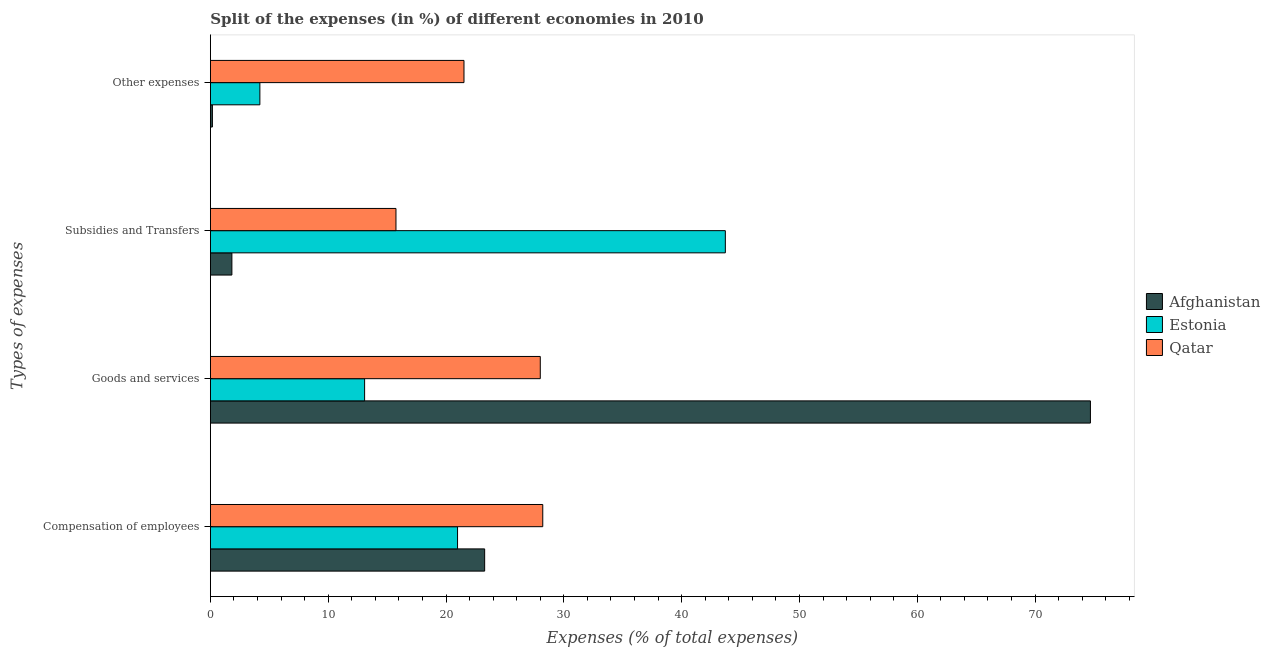How many different coloured bars are there?
Provide a succinct answer. 3. Are the number of bars on each tick of the Y-axis equal?
Your answer should be very brief. Yes. How many bars are there on the 1st tick from the top?
Provide a succinct answer. 3. How many bars are there on the 4th tick from the bottom?
Make the answer very short. 3. What is the label of the 3rd group of bars from the top?
Give a very brief answer. Goods and services. What is the percentage of amount spent on other expenses in Afghanistan?
Provide a succinct answer. 0.17. Across all countries, what is the maximum percentage of amount spent on goods and services?
Provide a short and direct response. 74.7. Across all countries, what is the minimum percentage of amount spent on subsidies?
Offer a very short reply. 1.82. In which country was the percentage of amount spent on compensation of employees maximum?
Offer a very short reply. Qatar. In which country was the percentage of amount spent on other expenses minimum?
Make the answer very short. Afghanistan. What is the total percentage of amount spent on goods and services in the graph?
Keep it short and to the point. 115.79. What is the difference between the percentage of amount spent on subsidies in Qatar and that in Afghanistan?
Ensure brevity in your answer.  13.93. What is the difference between the percentage of amount spent on compensation of employees in Estonia and the percentage of amount spent on subsidies in Qatar?
Ensure brevity in your answer.  5.23. What is the average percentage of amount spent on goods and services per country?
Keep it short and to the point. 38.6. What is the difference between the percentage of amount spent on goods and services and percentage of amount spent on compensation of employees in Estonia?
Offer a terse response. -7.89. What is the ratio of the percentage of amount spent on goods and services in Estonia to that in Afghanistan?
Your response must be concise. 0.18. Is the percentage of amount spent on goods and services in Estonia less than that in Afghanistan?
Offer a very short reply. Yes. What is the difference between the highest and the second highest percentage of amount spent on compensation of employees?
Your answer should be very brief. 4.93. What is the difference between the highest and the lowest percentage of amount spent on compensation of employees?
Give a very brief answer. 7.23. Is the sum of the percentage of amount spent on other expenses in Qatar and Estonia greater than the maximum percentage of amount spent on compensation of employees across all countries?
Ensure brevity in your answer.  No. What does the 3rd bar from the top in Compensation of employees represents?
Provide a succinct answer. Afghanistan. What does the 2nd bar from the bottom in Compensation of employees represents?
Give a very brief answer. Estonia. Is it the case that in every country, the sum of the percentage of amount spent on compensation of employees and percentage of amount spent on goods and services is greater than the percentage of amount spent on subsidies?
Your answer should be compact. No. How many bars are there?
Keep it short and to the point. 12. Are all the bars in the graph horizontal?
Offer a terse response. Yes. How many countries are there in the graph?
Make the answer very short. 3. What is the difference between two consecutive major ticks on the X-axis?
Offer a very short reply. 10. Are the values on the major ticks of X-axis written in scientific E-notation?
Give a very brief answer. No. Does the graph contain any zero values?
Your answer should be very brief. No. How are the legend labels stacked?
Your answer should be very brief. Vertical. What is the title of the graph?
Offer a terse response. Split of the expenses (in %) of different economies in 2010. What is the label or title of the X-axis?
Your answer should be very brief. Expenses (% of total expenses). What is the label or title of the Y-axis?
Provide a succinct answer. Types of expenses. What is the Expenses (% of total expenses) in Afghanistan in Compensation of employees?
Offer a very short reply. 23.28. What is the Expenses (% of total expenses) of Estonia in Compensation of employees?
Ensure brevity in your answer.  20.98. What is the Expenses (% of total expenses) in Qatar in Compensation of employees?
Your answer should be compact. 28.21. What is the Expenses (% of total expenses) in Afghanistan in Goods and services?
Provide a succinct answer. 74.7. What is the Expenses (% of total expenses) in Estonia in Goods and services?
Provide a succinct answer. 13.09. What is the Expenses (% of total expenses) in Qatar in Goods and services?
Ensure brevity in your answer.  28. What is the Expenses (% of total expenses) of Afghanistan in Subsidies and Transfers?
Make the answer very short. 1.82. What is the Expenses (% of total expenses) in Estonia in Subsidies and Transfers?
Offer a terse response. 43.71. What is the Expenses (% of total expenses) of Qatar in Subsidies and Transfers?
Provide a succinct answer. 15.75. What is the Expenses (% of total expenses) in Afghanistan in Other expenses?
Ensure brevity in your answer.  0.17. What is the Expenses (% of total expenses) of Estonia in Other expenses?
Offer a very short reply. 4.2. What is the Expenses (% of total expenses) of Qatar in Other expenses?
Provide a succinct answer. 21.53. Across all Types of expenses, what is the maximum Expenses (% of total expenses) of Afghanistan?
Give a very brief answer. 74.7. Across all Types of expenses, what is the maximum Expenses (% of total expenses) of Estonia?
Provide a succinct answer. 43.71. Across all Types of expenses, what is the maximum Expenses (% of total expenses) of Qatar?
Make the answer very short. 28.21. Across all Types of expenses, what is the minimum Expenses (% of total expenses) of Afghanistan?
Ensure brevity in your answer.  0.17. Across all Types of expenses, what is the minimum Expenses (% of total expenses) in Estonia?
Keep it short and to the point. 4.2. Across all Types of expenses, what is the minimum Expenses (% of total expenses) of Qatar?
Your answer should be very brief. 15.75. What is the total Expenses (% of total expenses) of Afghanistan in the graph?
Your answer should be very brief. 99.98. What is the total Expenses (% of total expenses) of Estonia in the graph?
Give a very brief answer. 81.98. What is the total Expenses (% of total expenses) in Qatar in the graph?
Make the answer very short. 93.49. What is the difference between the Expenses (% of total expenses) in Afghanistan in Compensation of employees and that in Goods and services?
Ensure brevity in your answer.  -51.42. What is the difference between the Expenses (% of total expenses) in Estonia in Compensation of employees and that in Goods and services?
Offer a terse response. 7.89. What is the difference between the Expenses (% of total expenses) in Qatar in Compensation of employees and that in Goods and services?
Provide a short and direct response. 0.21. What is the difference between the Expenses (% of total expenses) in Afghanistan in Compensation of employees and that in Subsidies and Transfers?
Provide a succinct answer. 21.46. What is the difference between the Expenses (% of total expenses) in Estonia in Compensation of employees and that in Subsidies and Transfers?
Your response must be concise. -22.73. What is the difference between the Expenses (% of total expenses) of Qatar in Compensation of employees and that in Subsidies and Transfers?
Make the answer very short. 12.46. What is the difference between the Expenses (% of total expenses) in Afghanistan in Compensation of employees and that in Other expenses?
Your answer should be compact. 23.11. What is the difference between the Expenses (% of total expenses) of Estonia in Compensation of employees and that in Other expenses?
Keep it short and to the point. 16.78. What is the difference between the Expenses (% of total expenses) of Qatar in Compensation of employees and that in Other expenses?
Ensure brevity in your answer.  6.69. What is the difference between the Expenses (% of total expenses) of Afghanistan in Goods and services and that in Subsidies and Transfers?
Offer a very short reply. 72.88. What is the difference between the Expenses (% of total expenses) of Estonia in Goods and services and that in Subsidies and Transfers?
Give a very brief answer. -30.62. What is the difference between the Expenses (% of total expenses) of Qatar in Goods and services and that in Subsidies and Transfers?
Provide a short and direct response. 12.25. What is the difference between the Expenses (% of total expenses) in Afghanistan in Goods and services and that in Other expenses?
Your response must be concise. 74.53. What is the difference between the Expenses (% of total expenses) of Estonia in Goods and services and that in Other expenses?
Provide a short and direct response. 8.89. What is the difference between the Expenses (% of total expenses) of Qatar in Goods and services and that in Other expenses?
Ensure brevity in your answer.  6.48. What is the difference between the Expenses (% of total expenses) in Afghanistan in Subsidies and Transfers and that in Other expenses?
Your answer should be very brief. 1.65. What is the difference between the Expenses (% of total expenses) of Estonia in Subsidies and Transfers and that in Other expenses?
Provide a succinct answer. 39.51. What is the difference between the Expenses (% of total expenses) in Qatar in Subsidies and Transfers and that in Other expenses?
Offer a very short reply. -5.77. What is the difference between the Expenses (% of total expenses) of Afghanistan in Compensation of employees and the Expenses (% of total expenses) of Estonia in Goods and services?
Your answer should be very brief. 10.19. What is the difference between the Expenses (% of total expenses) of Afghanistan in Compensation of employees and the Expenses (% of total expenses) of Qatar in Goods and services?
Ensure brevity in your answer.  -4.72. What is the difference between the Expenses (% of total expenses) of Estonia in Compensation of employees and the Expenses (% of total expenses) of Qatar in Goods and services?
Provide a short and direct response. -7.02. What is the difference between the Expenses (% of total expenses) in Afghanistan in Compensation of employees and the Expenses (% of total expenses) in Estonia in Subsidies and Transfers?
Your answer should be very brief. -20.43. What is the difference between the Expenses (% of total expenses) of Afghanistan in Compensation of employees and the Expenses (% of total expenses) of Qatar in Subsidies and Transfers?
Offer a terse response. 7.53. What is the difference between the Expenses (% of total expenses) of Estonia in Compensation of employees and the Expenses (% of total expenses) of Qatar in Subsidies and Transfers?
Make the answer very short. 5.23. What is the difference between the Expenses (% of total expenses) in Afghanistan in Compensation of employees and the Expenses (% of total expenses) in Estonia in Other expenses?
Offer a terse response. 19.08. What is the difference between the Expenses (% of total expenses) in Afghanistan in Compensation of employees and the Expenses (% of total expenses) in Qatar in Other expenses?
Keep it short and to the point. 1.75. What is the difference between the Expenses (% of total expenses) in Estonia in Compensation of employees and the Expenses (% of total expenses) in Qatar in Other expenses?
Provide a short and direct response. -0.55. What is the difference between the Expenses (% of total expenses) of Afghanistan in Goods and services and the Expenses (% of total expenses) of Estonia in Subsidies and Transfers?
Your answer should be very brief. 30.99. What is the difference between the Expenses (% of total expenses) in Afghanistan in Goods and services and the Expenses (% of total expenses) in Qatar in Subsidies and Transfers?
Provide a succinct answer. 58.95. What is the difference between the Expenses (% of total expenses) in Estonia in Goods and services and the Expenses (% of total expenses) in Qatar in Subsidies and Transfers?
Your answer should be very brief. -2.66. What is the difference between the Expenses (% of total expenses) of Afghanistan in Goods and services and the Expenses (% of total expenses) of Estonia in Other expenses?
Offer a very short reply. 70.5. What is the difference between the Expenses (% of total expenses) of Afghanistan in Goods and services and the Expenses (% of total expenses) of Qatar in Other expenses?
Your response must be concise. 53.17. What is the difference between the Expenses (% of total expenses) of Estonia in Goods and services and the Expenses (% of total expenses) of Qatar in Other expenses?
Offer a terse response. -8.44. What is the difference between the Expenses (% of total expenses) in Afghanistan in Subsidies and Transfers and the Expenses (% of total expenses) in Estonia in Other expenses?
Provide a succinct answer. -2.38. What is the difference between the Expenses (% of total expenses) of Afghanistan in Subsidies and Transfers and the Expenses (% of total expenses) of Qatar in Other expenses?
Offer a terse response. -19.7. What is the difference between the Expenses (% of total expenses) in Estonia in Subsidies and Transfers and the Expenses (% of total expenses) in Qatar in Other expenses?
Make the answer very short. 22.18. What is the average Expenses (% of total expenses) in Afghanistan per Types of expenses?
Make the answer very short. 24.99. What is the average Expenses (% of total expenses) in Estonia per Types of expenses?
Offer a terse response. 20.5. What is the average Expenses (% of total expenses) of Qatar per Types of expenses?
Provide a succinct answer. 23.37. What is the difference between the Expenses (% of total expenses) in Afghanistan and Expenses (% of total expenses) in Estonia in Compensation of employees?
Provide a succinct answer. 2.3. What is the difference between the Expenses (% of total expenses) of Afghanistan and Expenses (% of total expenses) of Qatar in Compensation of employees?
Your answer should be compact. -4.93. What is the difference between the Expenses (% of total expenses) in Estonia and Expenses (% of total expenses) in Qatar in Compensation of employees?
Offer a very short reply. -7.23. What is the difference between the Expenses (% of total expenses) in Afghanistan and Expenses (% of total expenses) in Estonia in Goods and services?
Make the answer very short. 61.61. What is the difference between the Expenses (% of total expenses) of Afghanistan and Expenses (% of total expenses) of Qatar in Goods and services?
Your answer should be compact. 46.7. What is the difference between the Expenses (% of total expenses) in Estonia and Expenses (% of total expenses) in Qatar in Goods and services?
Offer a terse response. -14.91. What is the difference between the Expenses (% of total expenses) in Afghanistan and Expenses (% of total expenses) in Estonia in Subsidies and Transfers?
Provide a succinct answer. -41.89. What is the difference between the Expenses (% of total expenses) in Afghanistan and Expenses (% of total expenses) in Qatar in Subsidies and Transfers?
Offer a very short reply. -13.93. What is the difference between the Expenses (% of total expenses) in Estonia and Expenses (% of total expenses) in Qatar in Subsidies and Transfers?
Your answer should be compact. 27.96. What is the difference between the Expenses (% of total expenses) of Afghanistan and Expenses (% of total expenses) of Estonia in Other expenses?
Your answer should be compact. -4.03. What is the difference between the Expenses (% of total expenses) of Afghanistan and Expenses (% of total expenses) of Qatar in Other expenses?
Ensure brevity in your answer.  -21.35. What is the difference between the Expenses (% of total expenses) in Estonia and Expenses (% of total expenses) in Qatar in Other expenses?
Offer a terse response. -17.32. What is the ratio of the Expenses (% of total expenses) of Afghanistan in Compensation of employees to that in Goods and services?
Offer a very short reply. 0.31. What is the ratio of the Expenses (% of total expenses) in Estonia in Compensation of employees to that in Goods and services?
Offer a very short reply. 1.6. What is the ratio of the Expenses (% of total expenses) in Qatar in Compensation of employees to that in Goods and services?
Ensure brevity in your answer.  1.01. What is the ratio of the Expenses (% of total expenses) in Afghanistan in Compensation of employees to that in Subsidies and Transfers?
Offer a terse response. 12.76. What is the ratio of the Expenses (% of total expenses) in Estonia in Compensation of employees to that in Subsidies and Transfers?
Your answer should be very brief. 0.48. What is the ratio of the Expenses (% of total expenses) of Qatar in Compensation of employees to that in Subsidies and Transfers?
Your response must be concise. 1.79. What is the ratio of the Expenses (% of total expenses) of Afghanistan in Compensation of employees to that in Other expenses?
Keep it short and to the point. 135.88. What is the ratio of the Expenses (% of total expenses) of Estonia in Compensation of employees to that in Other expenses?
Make the answer very short. 4.99. What is the ratio of the Expenses (% of total expenses) in Qatar in Compensation of employees to that in Other expenses?
Offer a very short reply. 1.31. What is the ratio of the Expenses (% of total expenses) of Afghanistan in Goods and services to that in Subsidies and Transfers?
Provide a short and direct response. 40.93. What is the ratio of the Expenses (% of total expenses) of Estonia in Goods and services to that in Subsidies and Transfers?
Keep it short and to the point. 0.3. What is the ratio of the Expenses (% of total expenses) of Qatar in Goods and services to that in Subsidies and Transfers?
Keep it short and to the point. 1.78. What is the ratio of the Expenses (% of total expenses) of Afghanistan in Goods and services to that in Other expenses?
Keep it short and to the point. 436.01. What is the ratio of the Expenses (% of total expenses) of Estonia in Goods and services to that in Other expenses?
Your response must be concise. 3.12. What is the ratio of the Expenses (% of total expenses) of Qatar in Goods and services to that in Other expenses?
Provide a short and direct response. 1.3. What is the ratio of the Expenses (% of total expenses) in Afghanistan in Subsidies and Transfers to that in Other expenses?
Provide a short and direct response. 10.65. What is the ratio of the Expenses (% of total expenses) in Estonia in Subsidies and Transfers to that in Other expenses?
Your answer should be compact. 10.4. What is the ratio of the Expenses (% of total expenses) of Qatar in Subsidies and Transfers to that in Other expenses?
Keep it short and to the point. 0.73. What is the difference between the highest and the second highest Expenses (% of total expenses) of Afghanistan?
Your answer should be very brief. 51.42. What is the difference between the highest and the second highest Expenses (% of total expenses) of Estonia?
Your answer should be compact. 22.73. What is the difference between the highest and the second highest Expenses (% of total expenses) of Qatar?
Give a very brief answer. 0.21. What is the difference between the highest and the lowest Expenses (% of total expenses) in Afghanistan?
Ensure brevity in your answer.  74.53. What is the difference between the highest and the lowest Expenses (% of total expenses) in Estonia?
Your answer should be compact. 39.51. What is the difference between the highest and the lowest Expenses (% of total expenses) in Qatar?
Your answer should be compact. 12.46. 